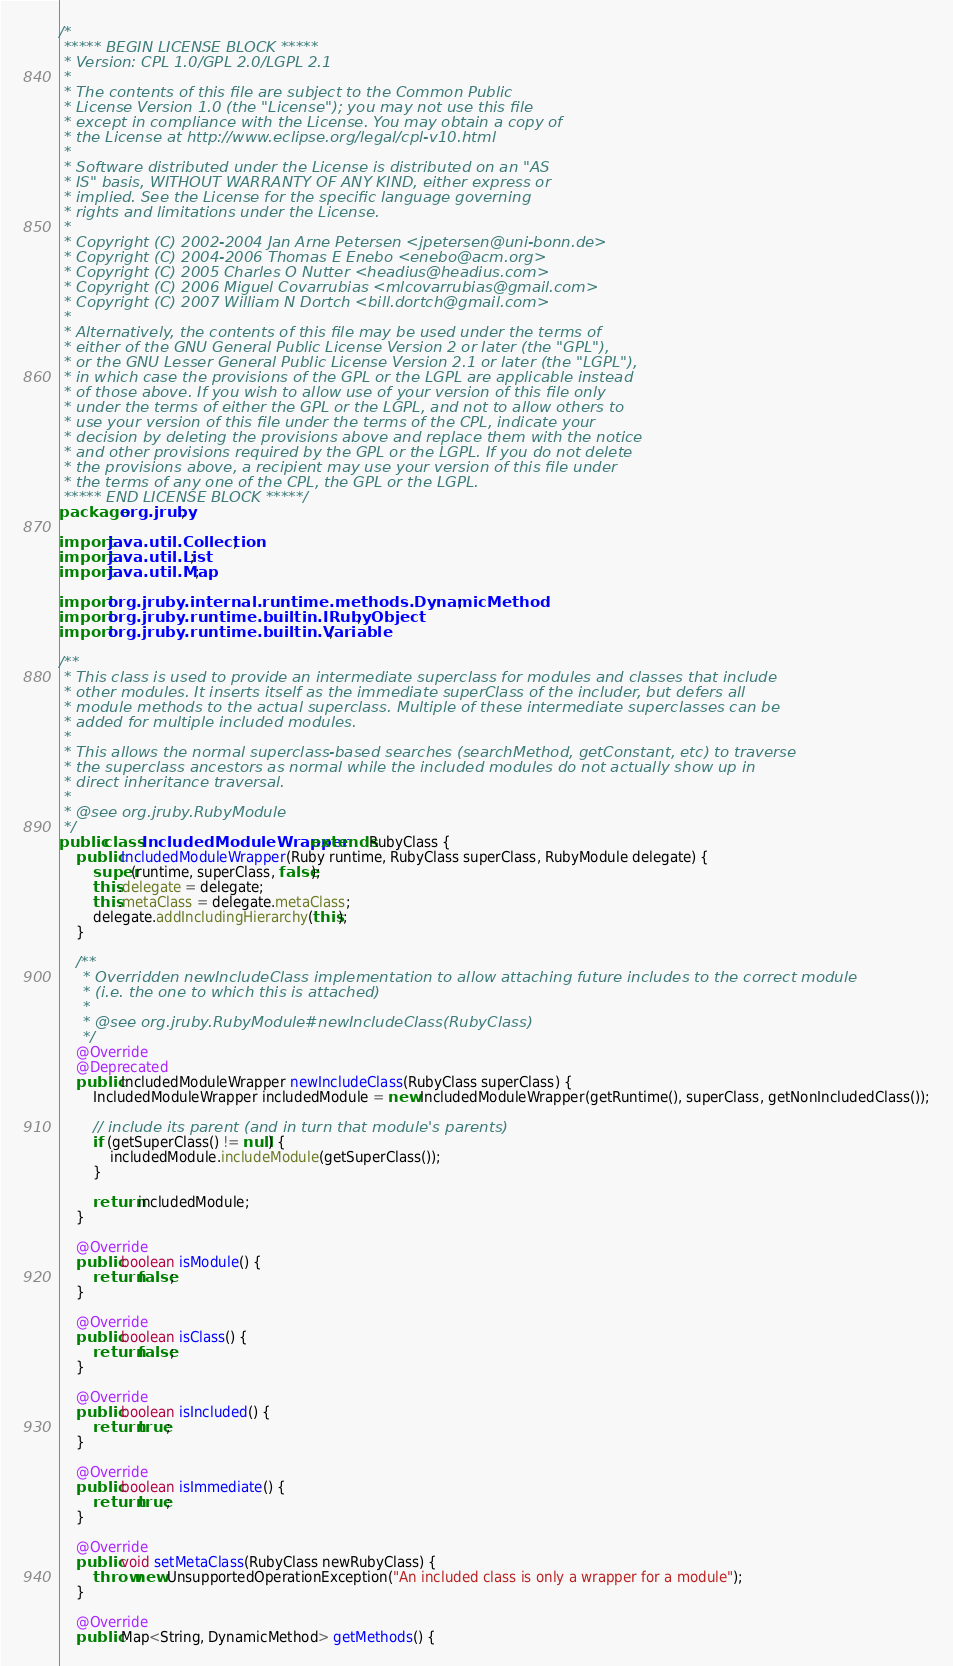<code> <loc_0><loc_0><loc_500><loc_500><_Java_>/*
 ***** BEGIN LICENSE BLOCK *****
 * Version: CPL 1.0/GPL 2.0/LGPL 2.1
 *
 * The contents of this file are subject to the Common Public
 * License Version 1.0 (the "License"); you may not use this file
 * except in compliance with the License. You may obtain a copy of
 * the License at http://www.eclipse.org/legal/cpl-v10.html
 *
 * Software distributed under the License is distributed on an "AS
 * IS" basis, WITHOUT WARRANTY OF ANY KIND, either express or
 * implied. See the License for the specific language governing
 * rights and limitations under the License.
 *
 * Copyright (C) 2002-2004 Jan Arne Petersen <jpetersen@uni-bonn.de>
 * Copyright (C) 2004-2006 Thomas E Enebo <enebo@acm.org>
 * Copyright (C) 2005 Charles O Nutter <headius@headius.com>
 * Copyright (C) 2006 Miguel Covarrubias <mlcovarrubias@gmail.com>
 * Copyright (C) 2007 William N Dortch <bill.dortch@gmail.com>
 * 
 * Alternatively, the contents of this file may be used under the terms of
 * either of the GNU General Public License Version 2 or later (the "GPL"),
 * or the GNU Lesser General Public License Version 2.1 or later (the "LGPL"),
 * in which case the provisions of the GPL or the LGPL are applicable instead
 * of those above. If you wish to allow use of your version of this file only
 * under the terms of either the GPL or the LGPL, and not to allow others to
 * use your version of this file under the terms of the CPL, indicate your
 * decision by deleting the provisions above and replace them with the notice
 * and other provisions required by the GPL or the LGPL. If you do not delete
 * the provisions above, a recipient may use your version of this file under
 * the terms of any one of the CPL, the GPL or the LGPL.
 ***** END LICENSE BLOCK *****/
package org.jruby;

import java.util.Collection;
import java.util.List;
import java.util.Map;

import org.jruby.internal.runtime.methods.DynamicMethod;
import org.jruby.runtime.builtin.IRubyObject;
import org.jruby.runtime.builtin.Variable;

/**
 * This class is used to provide an intermediate superclass for modules and classes that include
 * other modules. It inserts itself as the immediate superClass of the includer, but defers all
 * module methods to the actual superclass. Multiple of these intermediate superclasses can be
 * added for multiple included modules.
 * 
 * This allows the normal superclass-based searches (searchMethod, getConstant, etc) to traverse
 * the superclass ancestors as normal while the included modules do not actually show up in
 * direct inheritance traversal.
 * 
 * @see org.jruby.RubyModule
 */
public class IncludedModuleWrapper extends RubyClass {
    public IncludedModuleWrapper(Ruby runtime, RubyClass superClass, RubyModule delegate) {
        super(runtime, superClass, false);
        this.delegate = delegate;
        this.metaClass = delegate.metaClass;
        delegate.addIncludingHierarchy(this);
    }

    /**
     * Overridden newIncludeClass implementation to allow attaching future includes to the correct module
     * (i.e. the one to which this is attached)
     * 
     * @see org.jruby.RubyModule#newIncludeClass(RubyClass)
     */
    @Override
    @Deprecated
    public IncludedModuleWrapper newIncludeClass(RubyClass superClass) {
        IncludedModuleWrapper includedModule = new IncludedModuleWrapper(getRuntime(), superClass, getNonIncludedClass());
        
        // include its parent (and in turn that module's parents)
        if (getSuperClass() != null) {
            includedModule.includeModule(getSuperClass());
        }
        
        return includedModule;
    }

    @Override
    public boolean isModule() {
        return false;
    }

    @Override
    public boolean isClass() {
        return false;
    }

    @Override
    public boolean isIncluded() {
        return true;
    }
    
    @Override
    public boolean isImmediate() {
        return true;
    }

    @Override
    public void setMetaClass(RubyClass newRubyClass) {
        throw new UnsupportedOperationException("An included class is only a wrapper for a module");
    }

    @Override
    public Map<String, DynamicMethod> getMethods() {</code> 